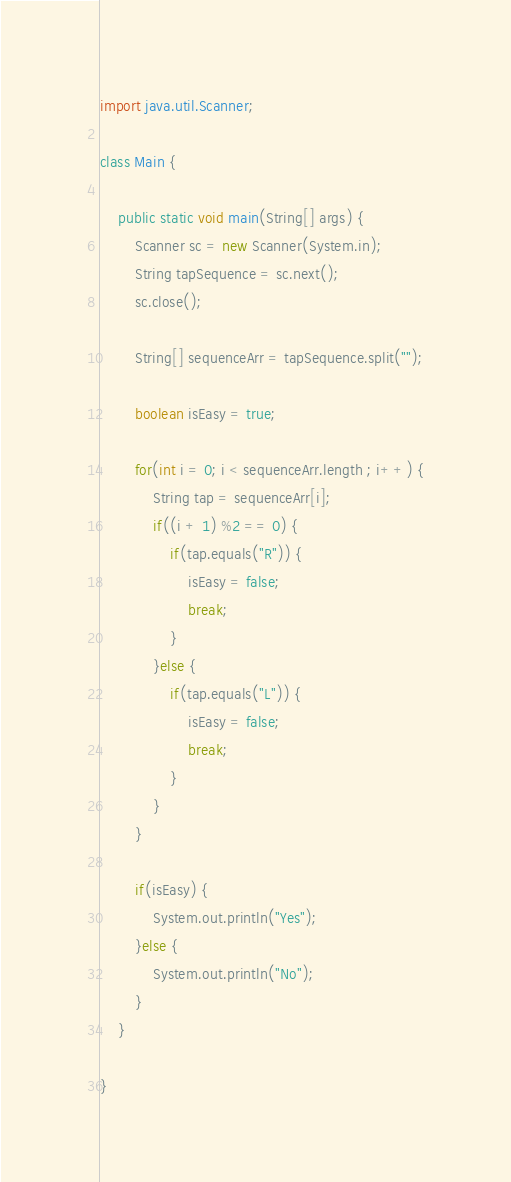Convert code to text. <code><loc_0><loc_0><loc_500><loc_500><_Java_>import java.util.Scanner;

class Main {
	
	public static void main(String[] args) {
		Scanner sc = new Scanner(System.in);
		String tapSequence = sc.next();
		sc.close();
		
		String[] sequenceArr = tapSequence.split("");
		
		boolean isEasy = true;
		
		for(int i = 0; i < sequenceArr.length ; i++) {
			String tap = sequenceArr[i];
			if((i + 1) %2 == 0) {
				if(tap.equals("R")) {
					isEasy = false;
					break;
				}
			}else {
				if(tap.equals("L")) {
					isEasy = false;
					break;
				}
			}
		}
		
		if(isEasy) {
			System.out.println("Yes");
		}else {
			System.out.println("No");
		}		
	}

}
</code> 